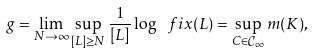Convert formula to latex. <formula><loc_0><loc_0><loc_500><loc_500>g = \lim _ { N \to \infty } \sup _ { [ L ] \geq N } \frac { 1 } { [ L ] } \log \ f i x ( L ) = \sup _ { C \in \mathcal { C } _ { \infty } } m ( K ) ,</formula> 